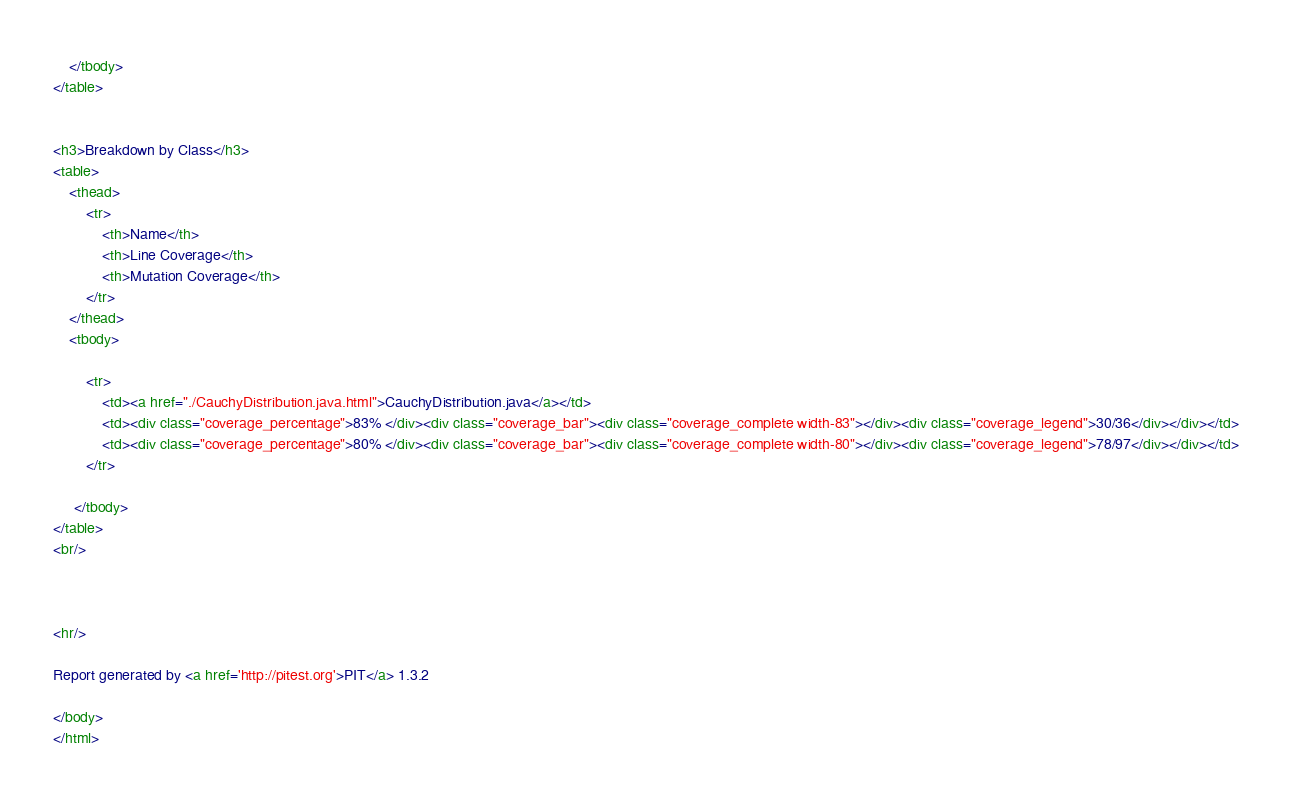<code> <loc_0><loc_0><loc_500><loc_500><_HTML_>    </tbody>
</table>


<h3>Breakdown by Class</h3>
<table>
    <thead>
        <tr>
            <th>Name</th>
            <th>Line Coverage</th>
            <th>Mutation Coverage</th>
        </tr>
    </thead>
    <tbody>

        <tr>
            <td><a href="./CauchyDistribution.java.html">CauchyDistribution.java</a></td>
            <td><div class="coverage_percentage">83% </div><div class="coverage_bar"><div class="coverage_complete width-83"></div><div class="coverage_legend">30/36</div></div></td>
            <td><div class="coverage_percentage">80% </div><div class="coverage_bar"><div class="coverage_complete width-80"></div><div class="coverage_legend">78/97</div></div></td>
        </tr>

     </tbody>
</table>
<br/>



<hr/>

Report generated by <a href='http://pitest.org'>PIT</a> 1.3.2

</body>
</html></code> 